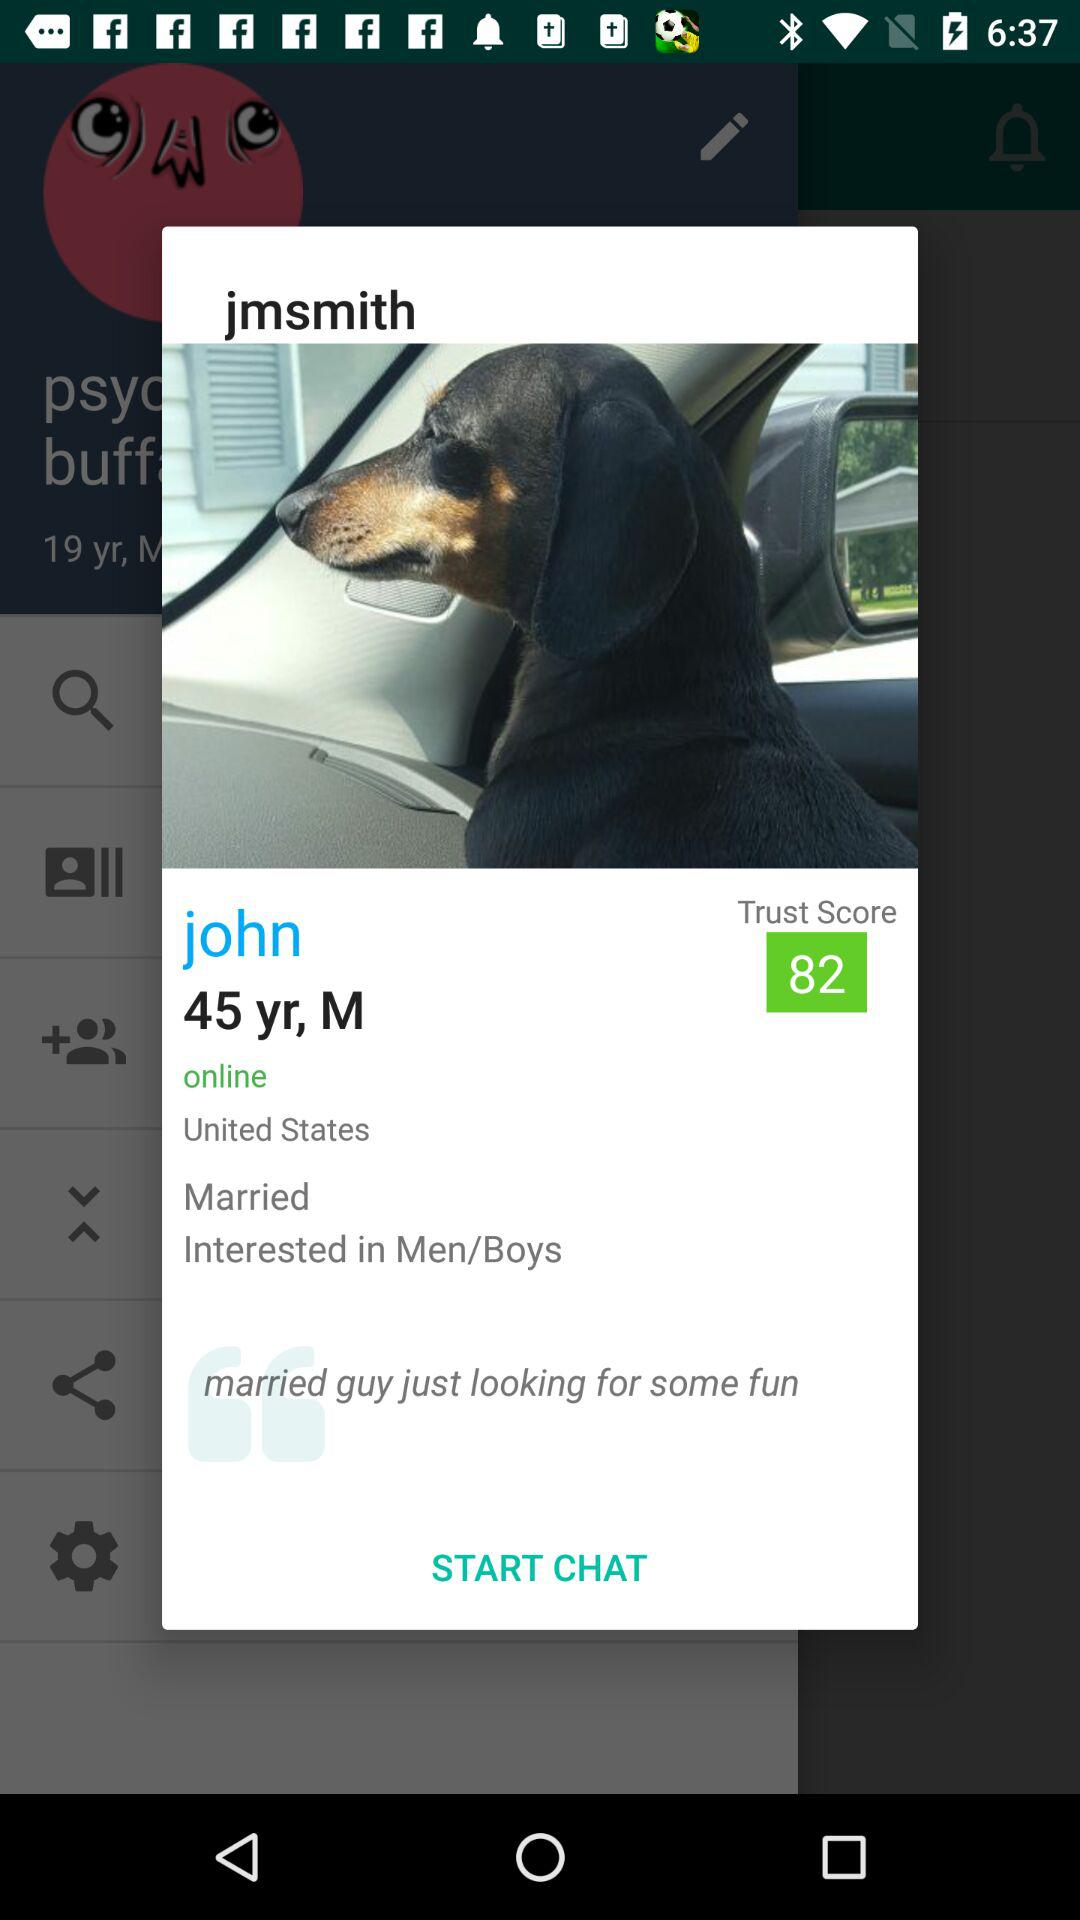What is the gender of "john"? The gender is male. 